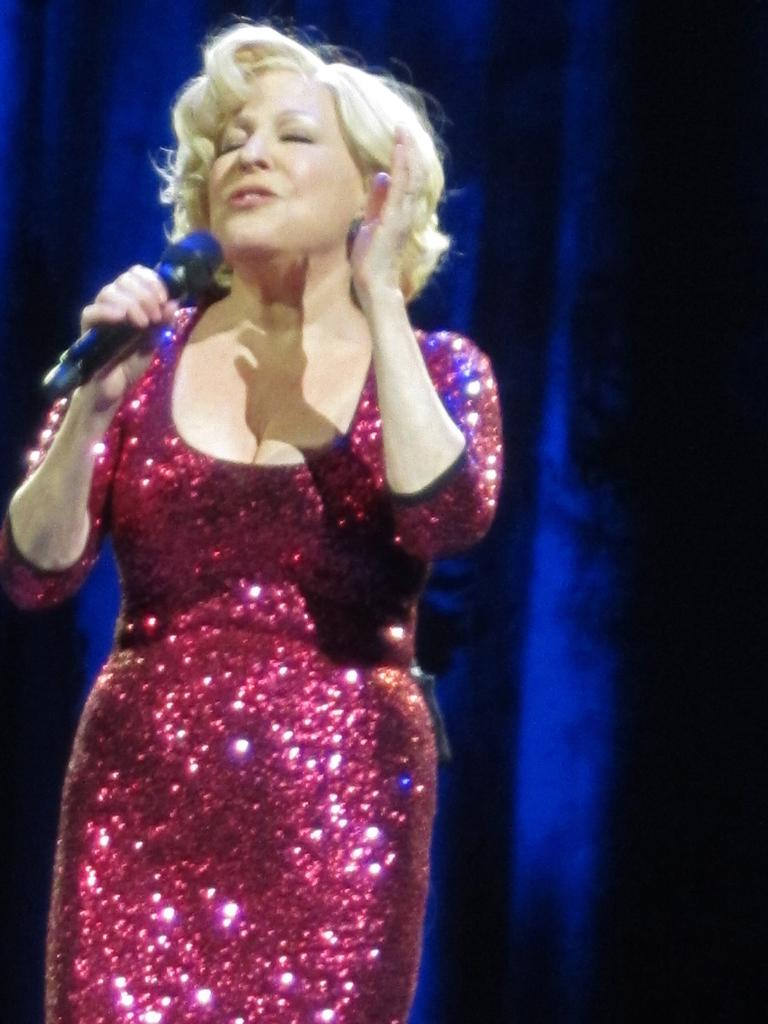What is the person in the image doing? The person is singing. What object is the person holding in the image? The person is holding a microphone. What is the person wearing in the image? The person is wearing a maroon color dress. What can be seen in the background of the image? There is a purple color curtain in the background of the image. What type of fruit is the person eating in the image? There is no fruit present in the image; the person is holding a microphone and singing. How many sons does the person have, and what are their names? There is no information about the person's family in the image, so we cannot determine the number of sons or their names. 